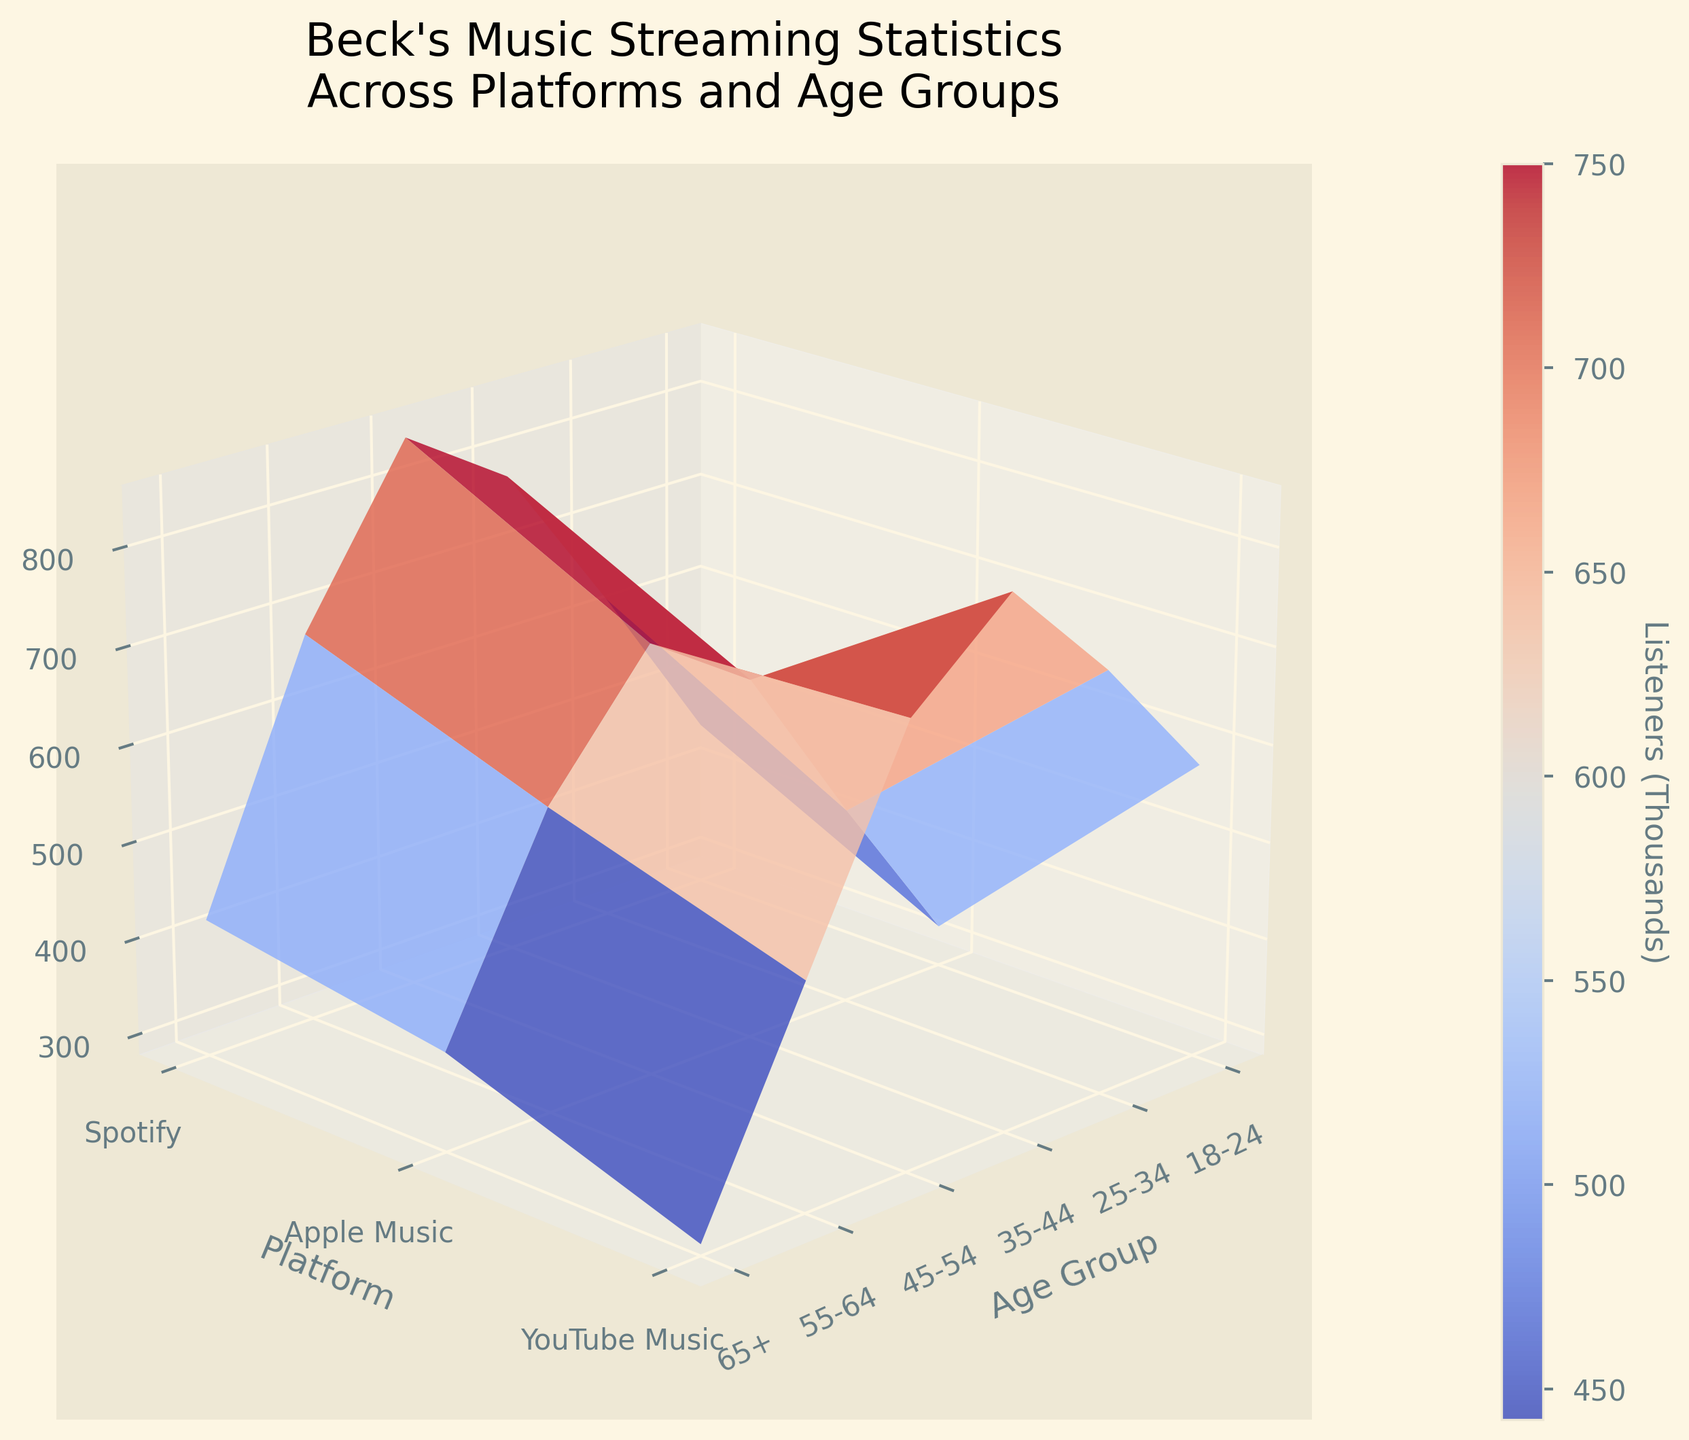What is the title of the plot? The title of the plot is written at the top of the figure. It usually summarizes the main topic or findings the plot represents. In this case, you'll see the title as "Beck's Music Streaming Statistics Across Platforms and Age Groups".
Answer: Beck's Music Streaming Statistics Across Platforms and Age Groups Which age group has the highest number of listeners on Spotify? To determine this, look at the peak values on the Spotify axis (labeled by the 'Platform' axis) and find the highest point. Checking the values for each age group, the 45-54 age group has the highest number, around 850,000 listeners.
Answer: 45-54 Which platform has the least listeners in the 65+ age group? Look at the end of the age group axis for 65+ and compare the heights of the respective platforms. The data shows 290,000 for YouTube Music, which is the smallest number.
Answer: YouTube Music What is the combined number of listeners for the 25-34 age group across all platforms? Add the number of listeners for the 25-34 age group from each platform: 620,000 (Spotify) + 480,000 (Apple Music) + 710,000 (YouTube Music). This sums up to 1,810,000.
Answer: 1,810,000 How does YouTube Music's listener count in the 35-44 age group compare to Apple Music's in the same group? Compare the heights of the surface plot for the 35-44 age group for both platforms. YouTube Music has 820,000 listeners, while Apple Music has 650,000. YouTube Music has more.
Answer: YouTube Music has more What is the average number of listeners across all platforms for the 45-54 age group? Add the number of listeners for each platform in the 45-54 age group and then divide by the number of platforms: (850,000 + 720,000 + 730,000) / 3. This results in 2,300,000 / 3 ≈ 766,667 listeners.
Answer: Approximately 766,667 Between which age groups does Spotify see a noticeable decline in the number of listeners? Observe the trend of the surface plot in the Spotify axis. The largest decline happens between the 45-54 and 55-64 age groups, from 850,000 to 680,000 listeners.
Answer: 45-54 to 55-64 Is the number of Apple Music listeners higher or lower than Spotify in the 35-44 age group? Compare the heights of the two platforms for the 35-44 age group. Apple Music has 650,000 listeners, while Spotify has 780,000 listeners, so Apple Music is lower.
Answer: Lower What seems to be the most popular platform among the 18-24 age group? Look at the surface heights for each platform in the 18-24 age group. YouTube Music is the highest, with 580,000 listeners.
Answer: YouTube Music From the plot, do older age groups (65+) prefer Spotify over Apple Music or vice versa? Compare the surface heights for the 65+ age group. Spotify has 420,000, while Apple Music has 380,000. Hence, older age groups prefer Spotify slightly more.
Answer: Spotify 